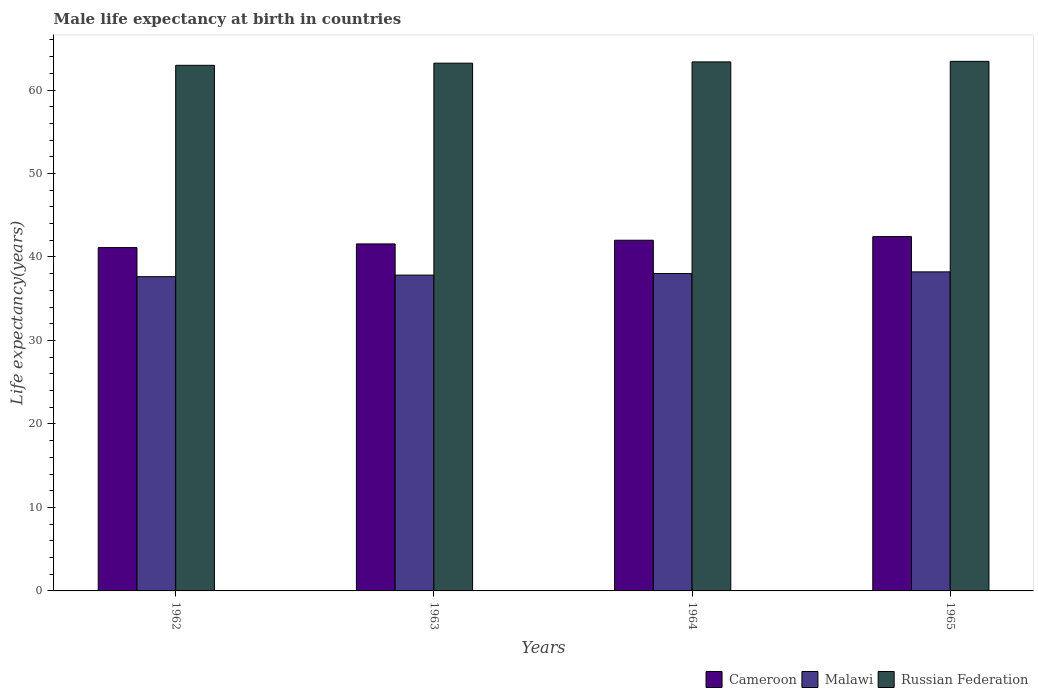How many different coloured bars are there?
Your response must be concise. 3. How many groups of bars are there?
Give a very brief answer. 4. How many bars are there on the 2nd tick from the left?
Keep it short and to the point. 3. How many bars are there on the 4th tick from the right?
Make the answer very short. 3. What is the label of the 2nd group of bars from the left?
Provide a succinct answer. 1963. What is the male life expectancy at birth in Russian Federation in 1963?
Keep it short and to the point. 63.22. Across all years, what is the maximum male life expectancy at birth in Malawi?
Your answer should be compact. 38.22. Across all years, what is the minimum male life expectancy at birth in Malawi?
Your answer should be very brief. 37.64. In which year was the male life expectancy at birth in Russian Federation maximum?
Your answer should be very brief. 1965. In which year was the male life expectancy at birth in Cameroon minimum?
Give a very brief answer. 1962. What is the total male life expectancy at birth in Cameroon in the graph?
Keep it short and to the point. 167.14. What is the difference between the male life expectancy at birth in Malawi in 1962 and that in 1963?
Provide a short and direct response. -0.19. What is the difference between the male life expectancy at birth in Cameroon in 1965 and the male life expectancy at birth in Russian Federation in 1962?
Offer a very short reply. -20.52. What is the average male life expectancy at birth in Malawi per year?
Provide a short and direct response. 37.93. In the year 1963, what is the difference between the male life expectancy at birth in Cameroon and male life expectancy at birth in Russian Federation?
Offer a very short reply. -21.65. What is the ratio of the male life expectancy at birth in Malawi in 1962 to that in 1965?
Offer a very short reply. 0.98. What is the difference between the highest and the second highest male life expectancy at birth in Cameroon?
Offer a very short reply. 0.44. What is the difference between the highest and the lowest male life expectancy at birth in Malawi?
Keep it short and to the point. 0.58. In how many years, is the male life expectancy at birth in Cameroon greater than the average male life expectancy at birth in Cameroon taken over all years?
Ensure brevity in your answer.  2. Is the sum of the male life expectancy at birth in Cameroon in 1963 and 1964 greater than the maximum male life expectancy at birth in Malawi across all years?
Offer a terse response. Yes. What does the 3rd bar from the left in 1965 represents?
Offer a terse response. Russian Federation. What does the 3rd bar from the right in 1965 represents?
Make the answer very short. Cameroon. Is it the case that in every year, the sum of the male life expectancy at birth in Cameroon and male life expectancy at birth in Malawi is greater than the male life expectancy at birth in Russian Federation?
Give a very brief answer. Yes. How many bars are there?
Provide a short and direct response. 12. Are all the bars in the graph horizontal?
Make the answer very short. No. What is the difference between two consecutive major ticks on the Y-axis?
Provide a succinct answer. 10. Are the values on the major ticks of Y-axis written in scientific E-notation?
Give a very brief answer. No. Does the graph contain grids?
Offer a very short reply. No. Where does the legend appear in the graph?
Provide a short and direct response. Bottom right. How many legend labels are there?
Your response must be concise. 3. What is the title of the graph?
Offer a very short reply. Male life expectancy at birth in countries. What is the label or title of the Y-axis?
Keep it short and to the point. Life expectancy(years). What is the Life expectancy(years) in Cameroon in 1962?
Provide a short and direct response. 41.12. What is the Life expectancy(years) in Malawi in 1962?
Keep it short and to the point. 37.64. What is the Life expectancy(years) in Russian Federation in 1962?
Provide a succinct answer. 62.96. What is the Life expectancy(years) of Cameroon in 1963?
Your answer should be very brief. 41.57. What is the Life expectancy(years) of Malawi in 1963?
Your answer should be compact. 37.83. What is the Life expectancy(years) of Russian Federation in 1963?
Your answer should be very brief. 63.22. What is the Life expectancy(years) of Cameroon in 1964?
Keep it short and to the point. 42.01. What is the Life expectancy(years) in Malawi in 1964?
Your response must be concise. 38.02. What is the Life expectancy(years) of Russian Federation in 1964?
Offer a terse response. 63.37. What is the Life expectancy(years) of Cameroon in 1965?
Your answer should be compact. 42.44. What is the Life expectancy(years) of Malawi in 1965?
Ensure brevity in your answer.  38.22. What is the Life expectancy(years) of Russian Federation in 1965?
Your response must be concise. 63.43. Across all years, what is the maximum Life expectancy(years) in Cameroon?
Your answer should be compact. 42.44. Across all years, what is the maximum Life expectancy(years) in Malawi?
Offer a terse response. 38.22. Across all years, what is the maximum Life expectancy(years) of Russian Federation?
Give a very brief answer. 63.43. Across all years, what is the minimum Life expectancy(years) in Cameroon?
Your answer should be very brief. 41.12. Across all years, what is the minimum Life expectancy(years) in Malawi?
Your answer should be compact. 37.64. Across all years, what is the minimum Life expectancy(years) of Russian Federation?
Provide a short and direct response. 62.96. What is the total Life expectancy(years) in Cameroon in the graph?
Your response must be concise. 167.14. What is the total Life expectancy(years) of Malawi in the graph?
Ensure brevity in your answer.  151.71. What is the total Life expectancy(years) of Russian Federation in the graph?
Provide a succinct answer. 252.97. What is the difference between the Life expectancy(years) of Cameroon in 1962 and that in 1963?
Your response must be concise. -0.44. What is the difference between the Life expectancy(years) in Malawi in 1962 and that in 1963?
Keep it short and to the point. -0.19. What is the difference between the Life expectancy(years) in Russian Federation in 1962 and that in 1963?
Offer a terse response. -0.26. What is the difference between the Life expectancy(years) in Cameroon in 1962 and that in 1964?
Provide a short and direct response. -0.88. What is the difference between the Life expectancy(years) of Malawi in 1962 and that in 1964?
Your response must be concise. -0.38. What is the difference between the Life expectancy(years) of Russian Federation in 1962 and that in 1964?
Your answer should be very brief. -0.41. What is the difference between the Life expectancy(years) in Cameroon in 1962 and that in 1965?
Your answer should be compact. -1.32. What is the difference between the Life expectancy(years) in Malawi in 1962 and that in 1965?
Provide a short and direct response. -0.58. What is the difference between the Life expectancy(years) in Russian Federation in 1962 and that in 1965?
Make the answer very short. -0.47. What is the difference between the Life expectancy(years) of Cameroon in 1963 and that in 1964?
Your answer should be very brief. -0.44. What is the difference between the Life expectancy(years) in Malawi in 1963 and that in 1964?
Offer a very short reply. -0.19. What is the difference between the Life expectancy(years) in Russian Federation in 1963 and that in 1964?
Your answer should be compact. -0.15. What is the difference between the Life expectancy(years) of Cameroon in 1963 and that in 1965?
Provide a short and direct response. -0.88. What is the difference between the Life expectancy(years) of Malawi in 1963 and that in 1965?
Offer a terse response. -0.39. What is the difference between the Life expectancy(years) in Russian Federation in 1963 and that in 1965?
Your answer should be very brief. -0.22. What is the difference between the Life expectancy(years) of Cameroon in 1964 and that in 1965?
Your response must be concise. -0.44. What is the difference between the Life expectancy(years) of Russian Federation in 1964 and that in 1965?
Provide a short and direct response. -0.07. What is the difference between the Life expectancy(years) of Cameroon in 1962 and the Life expectancy(years) of Malawi in 1963?
Keep it short and to the point. 3.29. What is the difference between the Life expectancy(years) in Cameroon in 1962 and the Life expectancy(years) in Russian Federation in 1963?
Keep it short and to the point. -22.09. What is the difference between the Life expectancy(years) of Malawi in 1962 and the Life expectancy(years) of Russian Federation in 1963?
Your answer should be compact. -25.57. What is the difference between the Life expectancy(years) in Cameroon in 1962 and the Life expectancy(years) in Malawi in 1964?
Offer a terse response. 3.11. What is the difference between the Life expectancy(years) of Cameroon in 1962 and the Life expectancy(years) of Russian Federation in 1964?
Your answer should be very brief. -22.24. What is the difference between the Life expectancy(years) of Malawi in 1962 and the Life expectancy(years) of Russian Federation in 1964?
Your answer should be compact. -25.73. What is the difference between the Life expectancy(years) of Cameroon in 1962 and the Life expectancy(years) of Malawi in 1965?
Make the answer very short. 2.91. What is the difference between the Life expectancy(years) in Cameroon in 1962 and the Life expectancy(years) in Russian Federation in 1965?
Your answer should be very brief. -22.31. What is the difference between the Life expectancy(years) of Malawi in 1962 and the Life expectancy(years) of Russian Federation in 1965?
Ensure brevity in your answer.  -25.79. What is the difference between the Life expectancy(years) in Cameroon in 1963 and the Life expectancy(years) in Malawi in 1964?
Provide a succinct answer. 3.55. What is the difference between the Life expectancy(years) in Cameroon in 1963 and the Life expectancy(years) in Russian Federation in 1964?
Provide a succinct answer. -21.8. What is the difference between the Life expectancy(years) of Malawi in 1963 and the Life expectancy(years) of Russian Federation in 1964?
Your answer should be very brief. -25.54. What is the difference between the Life expectancy(years) of Cameroon in 1963 and the Life expectancy(years) of Malawi in 1965?
Provide a succinct answer. 3.35. What is the difference between the Life expectancy(years) of Cameroon in 1963 and the Life expectancy(years) of Russian Federation in 1965?
Your answer should be compact. -21.87. What is the difference between the Life expectancy(years) in Malawi in 1963 and the Life expectancy(years) in Russian Federation in 1965?
Provide a succinct answer. -25.6. What is the difference between the Life expectancy(years) of Cameroon in 1964 and the Life expectancy(years) of Malawi in 1965?
Make the answer very short. 3.79. What is the difference between the Life expectancy(years) in Cameroon in 1964 and the Life expectancy(years) in Russian Federation in 1965?
Provide a short and direct response. -21.43. What is the difference between the Life expectancy(years) of Malawi in 1964 and the Life expectancy(years) of Russian Federation in 1965?
Keep it short and to the point. -25.42. What is the average Life expectancy(years) in Cameroon per year?
Make the answer very short. 41.78. What is the average Life expectancy(years) of Malawi per year?
Your answer should be very brief. 37.93. What is the average Life expectancy(years) in Russian Federation per year?
Ensure brevity in your answer.  63.24. In the year 1962, what is the difference between the Life expectancy(years) in Cameroon and Life expectancy(years) in Malawi?
Offer a very short reply. 3.48. In the year 1962, what is the difference between the Life expectancy(years) in Cameroon and Life expectancy(years) in Russian Federation?
Make the answer very short. -21.83. In the year 1962, what is the difference between the Life expectancy(years) in Malawi and Life expectancy(years) in Russian Federation?
Keep it short and to the point. -25.32. In the year 1963, what is the difference between the Life expectancy(years) of Cameroon and Life expectancy(years) of Malawi?
Give a very brief answer. 3.74. In the year 1963, what is the difference between the Life expectancy(years) in Cameroon and Life expectancy(years) in Russian Federation?
Give a very brief answer. -21.65. In the year 1963, what is the difference between the Life expectancy(years) of Malawi and Life expectancy(years) of Russian Federation?
Offer a very short reply. -25.39. In the year 1964, what is the difference between the Life expectancy(years) in Cameroon and Life expectancy(years) in Malawi?
Keep it short and to the point. 3.99. In the year 1964, what is the difference between the Life expectancy(years) in Cameroon and Life expectancy(years) in Russian Federation?
Your answer should be very brief. -21.36. In the year 1964, what is the difference between the Life expectancy(years) of Malawi and Life expectancy(years) of Russian Federation?
Make the answer very short. -25.35. In the year 1965, what is the difference between the Life expectancy(years) in Cameroon and Life expectancy(years) in Malawi?
Offer a very short reply. 4.22. In the year 1965, what is the difference between the Life expectancy(years) in Cameroon and Life expectancy(years) in Russian Federation?
Offer a very short reply. -20.99. In the year 1965, what is the difference between the Life expectancy(years) of Malawi and Life expectancy(years) of Russian Federation?
Ensure brevity in your answer.  -25.22. What is the ratio of the Life expectancy(years) of Cameroon in 1962 to that in 1963?
Provide a short and direct response. 0.99. What is the ratio of the Life expectancy(years) in Russian Federation in 1962 to that in 1963?
Your response must be concise. 1. What is the ratio of the Life expectancy(years) in Cameroon in 1962 to that in 1964?
Your answer should be compact. 0.98. What is the ratio of the Life expectancy(years) in Malawi in 1962 to that in 1964?
Provide a succinct answer. 0.99. What is the ratio of the Life expectancy(years) in Russian Federation in 1962 to that in 1964?
Make the answer very short. 0.99. What is the ratio of the Life expectancy(years) of Cameroon in 1962 to that in 1965?
Provide a short and direct response. 0.97. What is the ratio of the Life expectancy(years) of Malawi in 1962 to that in 1965?
Give a very brief answer. 0.98. What is the ratio of the Life expectancy(years) of Russian Federation in 1962 to that in 1965?
Give a very brief answer. 0.99. What is the ratio of the Life expectancy(years) of Malawi in 1963 to that in 1964?
Make the answer very short. 1. What is the ratio of the Life expectancy(years) in Cameroon in 1963 to that in 1965?
Offer a very short reply. 0.98. What is the ratio of the Life expectancy(years) of Malawi in 1963 to that in 1965?
Keep it short and to the point. 0.99. What is the ratio of the Life expectancy(years) of Malawi in 1964 to that in 1965?
Offer a very short reply. 0.99. What is the difference between the highest and the second highest Life expectancy(years) of Cameroon?
Your response must be concise. 0.44. What is the difference between the highest and the second highest Life expectancy(years) of Malawi?
Offer a very short reply. 0.2. What is the difference between the highest and the second highest Life expectancy(years) in Russian Federation?
Provide a succinct answer. 0.07. What is the difference between the highest and the lowest Life expectancy(years) in Cameroon?
Give a very brief answer. 1.32. What is the difference between the highest and the lowest Life expectancy(years) of Malawi?
Give a very brief answer. 0.58. What is the difference between the highest and the lowest Life expectancy(years) of Russian Federation?
Keep it short and to the point. 0.47. 